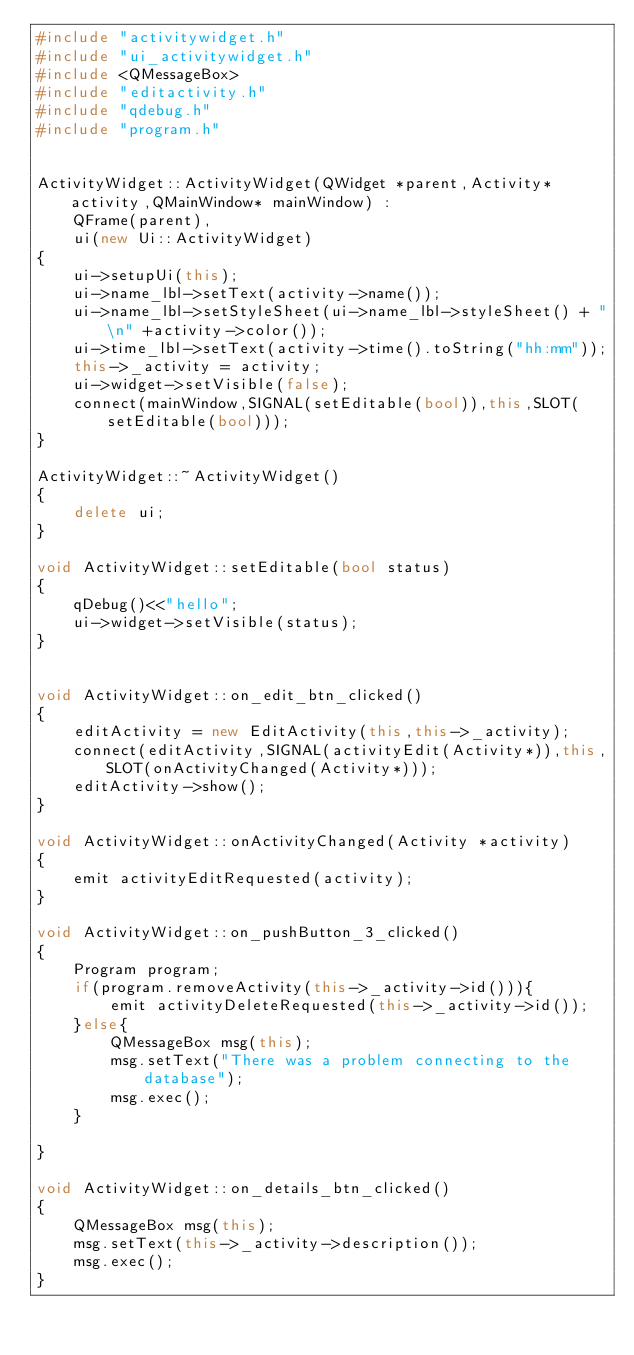<code> <loc_0><loc_0><loc_500><loc_500><_C++_>#include "activitywidget.h"
#include "ui_activitywidget.h"
#include <QMessageBox>
#include "editactivity.h"
#include "qdebug.h"
#include "program.h"


ActivityWidget::ActivityWidget(QWidget *parent,Activity* activity,QMainWindow* mainWindow) :
    QFrame(parent),
    ui(new Ui::ActivityWidget)
{
    ui->setupUi(this);
    ui->name_lbl->setText(activity->name());
    ui->name_lbl->setStyleSheet(ui->name_lbl->styleSheet() + "\n" +activity->color());
    ui->time_lbl->setText(activity->time().toString("hh:mm"));
    this->_activity = activity;
    ui->widget->setVisible(false);
    connect(mainWindow,SIGNAL(setEditable(bool)),this,SLOT(setEditable(bool)));
}

ActivityWidget::~ActivityWidget()
{
    delete ui;
}

void ActivityWidget::setEditable(bool status)
{
    qDebug()<<"hello";
    ui->widget->setVisible(status);
}


void ActivityWidget::on_edit_btn_clicked()
{
    editActivity = new EditActivity(this,this->_activity);
    connect(editActivity,SIGNAL(activityEdit(Activity*)),this,SLOT(onActivityChanged(Activity*)));
    editActivity->show();
}

void ActivityWidget::onActivityChanged(Activity *activity)
{
    emit activityEditRequested(activity);
}

void ActivityWidget::on_pushButton_3_clicked()
{
    Program program;
    if(program.removeActivity(this->_activity->id())){
        emit activityDeleteRequested(this->_activity->id());
    }else{
        QMessageBox msg(this);
        msg.setText("There was a problem connecting to the database");
        msg.exec();
    }

}

void ActivityWidget::on_details_btn_clicked()
{
    QMessageBox msg(this);
    msg.setText(this->_activity->description());
    msg.exec();
}
</code> 